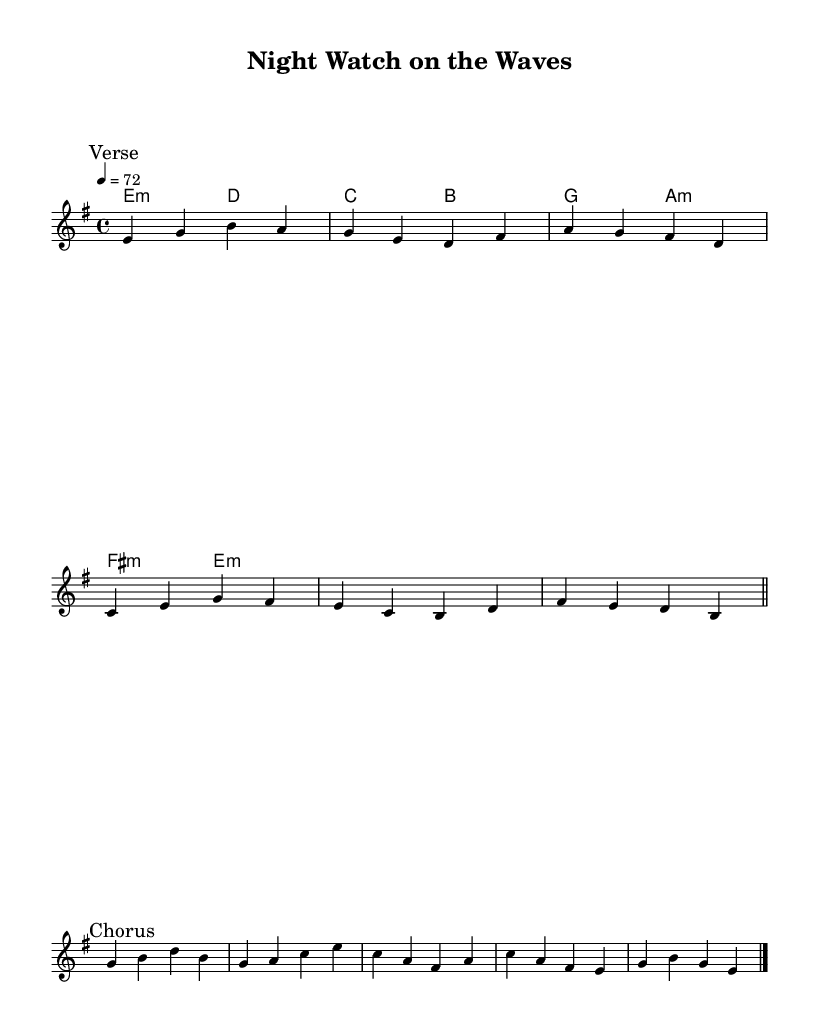What is the key signature of this music? The key signature is E minor, which has one sharp (F#). This is indicated in the global setting at the beginning of the score.
Answer: E minor What is the time signature of this music? The time signature is 4/4, meaning there are four beats per measure. This is specified in the global settings of the music sheet.
Answer: 4/4 What is the tempo marking for this piece? The tempo marking is 72 beats per minute, as indicated in the global settings section.
Answer: 72 How many measures are in the verse? The verse consists of 4 measures, as laid out in the melody verse section, ending with a bar line that denotes the end of the verse.
Answer: 4 What is the harmonic progression used in the chorus? The harmonic progression in the chorus is a sequence of E minor, D major, C major, and B major chords. This can be seen in the chord mode section of the score that corresponds to the melody lines.
Answer: E minor, D major, C major, B major Which voice part represents the melody? The melody is represented in the "melody" voice part, indicated in the score under the new Voice context.
Answer: melody What type of musical piece does this represent? This piece represents a rock ballad, indicated by its lyrical themes, emotional content, and structure typical of rock ballads.
Answer: Rock ballad 